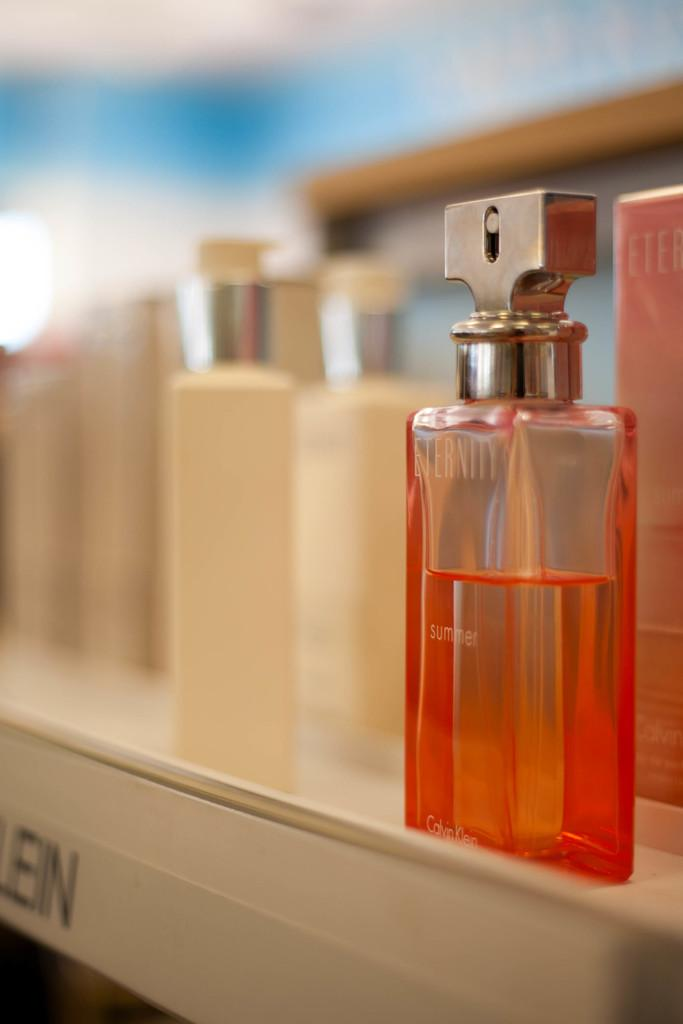<image>
Summarize the visual content of the image. Orange bottle of Eternity next to other bottles of perfume. 